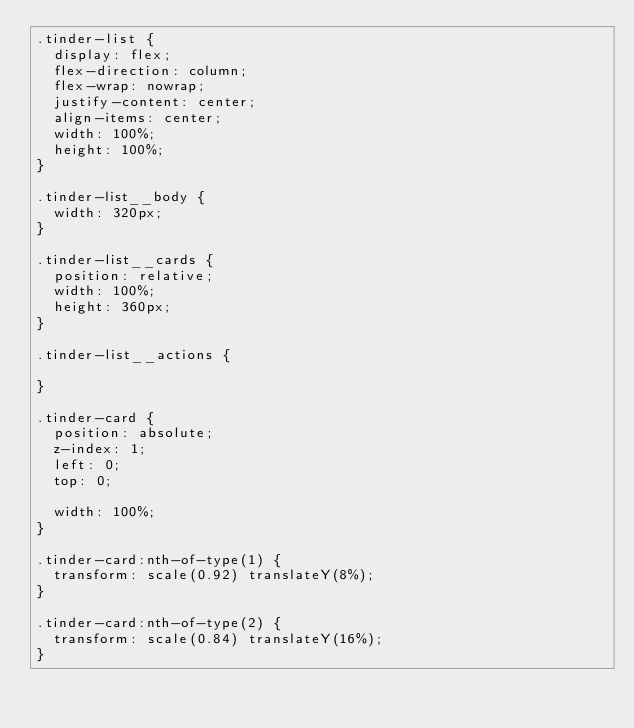Convert code to text. <code><loc_0><loc_0><loc_500><loc_500><_CSS_>.tinder-list {
  display: flex;
  flex-direction: column;
  flex-wrap: nowrap;
  justify-content: center;
  align-items: center;
  width: 100%;
  height: 100%;
}

.tinder-list__body {
  width: 320px;
}

.tinder-list__cards {
  position: relative;
  width: 100%;
  height: 360px;
}

.tinder-list__actions {
  
}

.tinder-card {
  position: absolute;
  z-index: 1;
  left: 0;
  top: 0;

  width: 100%;
}

.tinder-card:nth-of-type(1) {
  transform: scale(0.92) translateY(8%);
}

.tinder-card:nth-of-type(2) {
  transform: scale(0.84) translateY(16%);
}</code> 